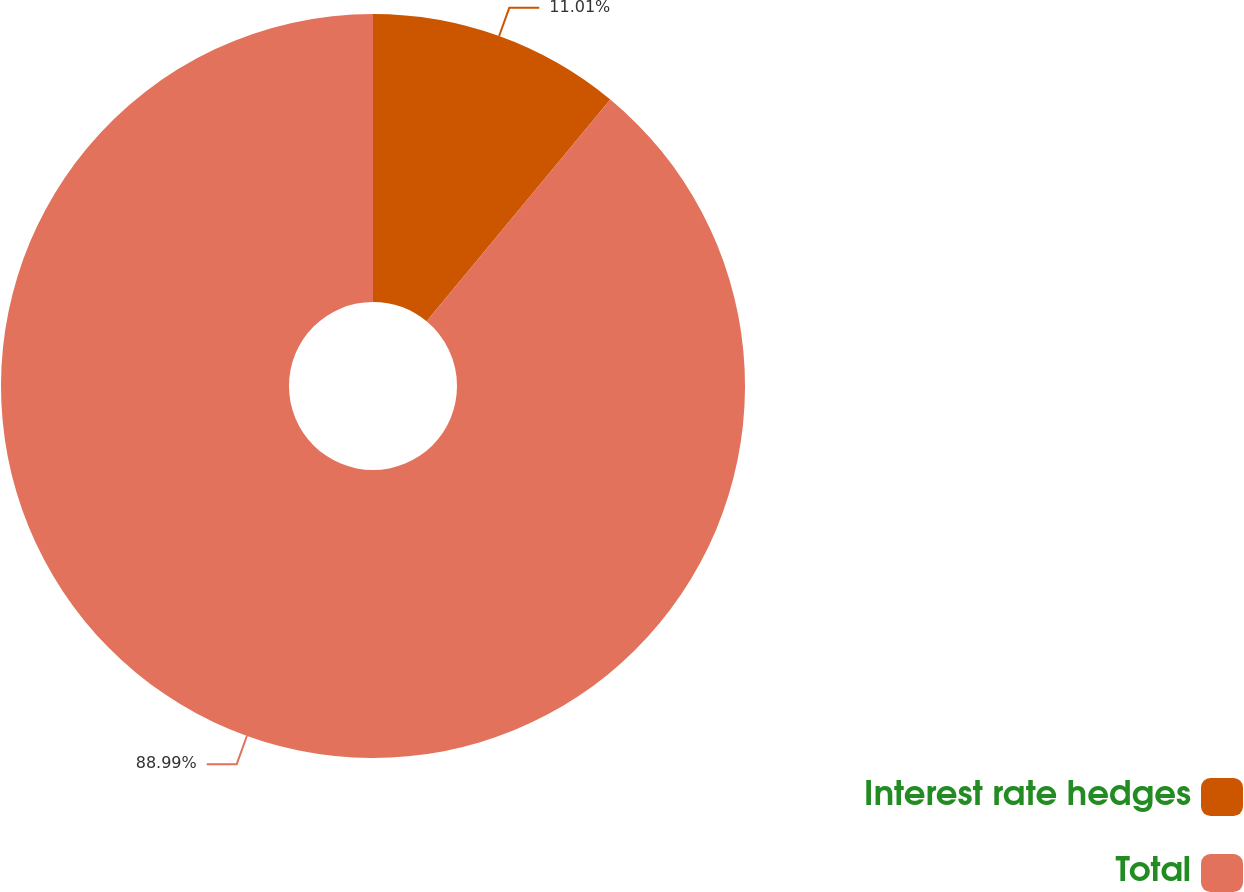Convert chart. <chart><loc_0><loc_0><loc_500><loc_500><pie_chart><fcel>Interest rate hedges<fcel>Total<nl><fcel>11.01%<fcel>88.99%<nl></chart> 